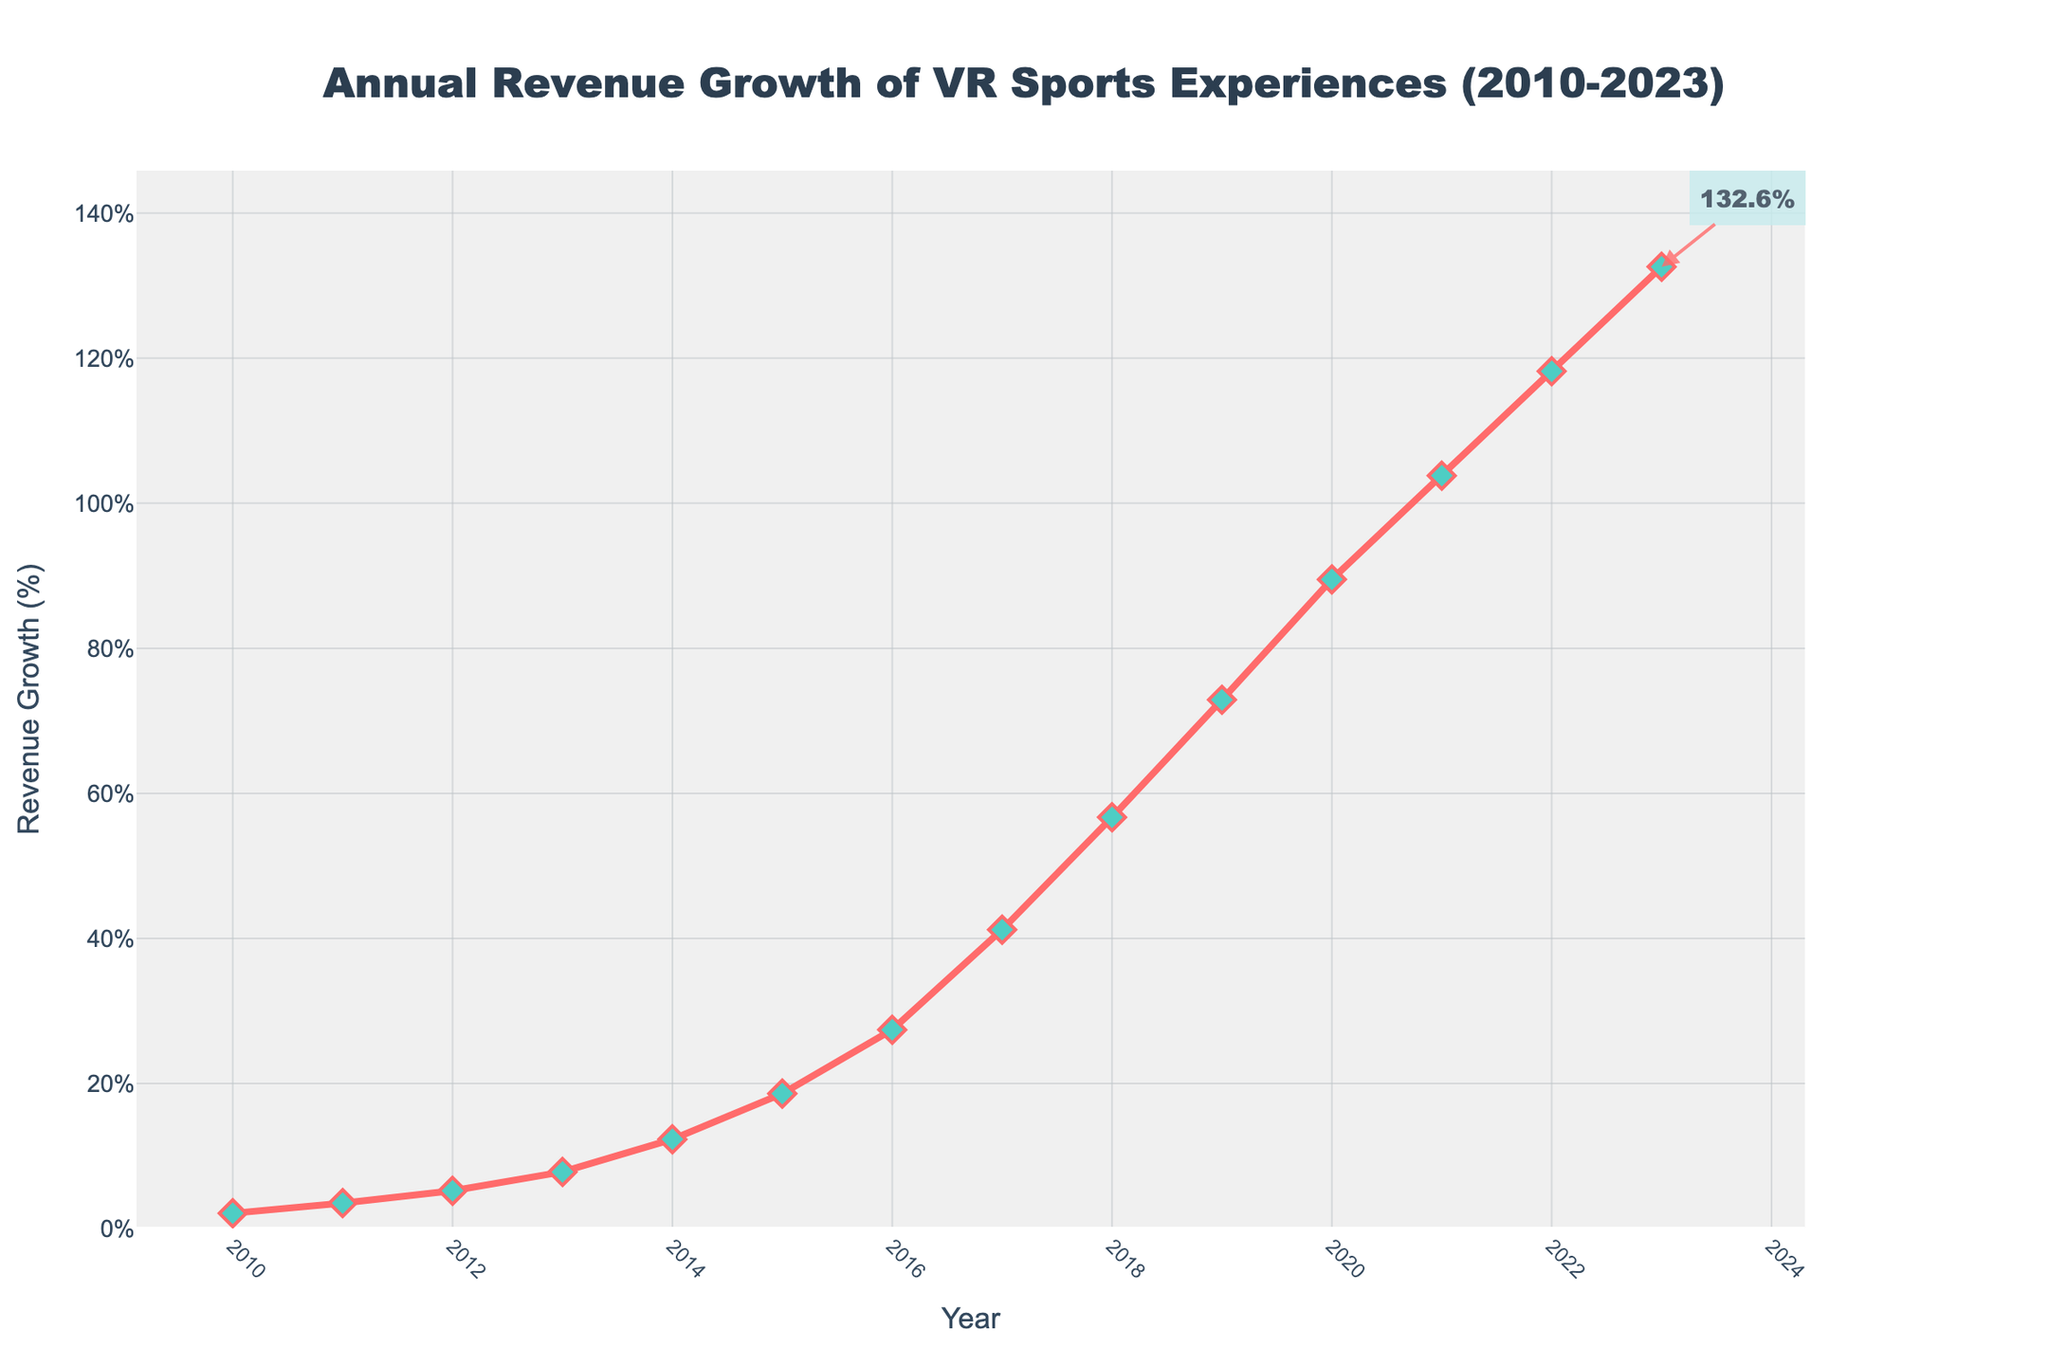What's the average annual revenue growth from 2010 to 2013? The revenue growth from 2010 to 2013 is 2.1%, 3.5%, 5.2%, and 7.8% respectively. Adding them: 2.1 + 3.5 + 5.2 + 7.8 = 18.6. Dividing by 4 gives the average: 18.6 / 4 = 4.65%
Answer: 4.65% Is the revenue growth in 2023 greater than in 2020? In 2023, the revenue growth is 132.6% and in 2020, it is 89.5%. Since 132.6 is greater than 89.5, the revenue growth in 2023 is greater than in 2020
Answer: Yes During which year did the revenue growth percentage surpass 50%? By looking at the data, we see that the revenue growth surpassed 50% in the year 2018 with a growth of 56.7%
Answer: 2018 How many times did the revenue growth increase by more than 15% from one year to the next? From 2010 to 2023: The increases above 15% are from 2016 to 2017 (27.4% to 41.2%, 13.8%), 2017 to 2018 (41.2% to 56.7%, 15.5%), 2018 to 2019 (56.7% to 72.9%, 16.2%), 2019 to 2020 (72.9% to 89.5%, 16.6%), 2020 to 2021 (89.5% to 103.8%, 14.3%), 2021 to 2022 (103.8% to 118.2%, 14.4%), and 2022 to 2023 (118.2% to 132.6%, 14.4%). Only the years 2017 to 2018, 2018 to 2019, and 2019 to 2020 show increases over 15%.
Answer: 3 What's the total revenue growth from 2010 to 2019? Adding the revenue growth percentages from 2010 to 2019: 2.1 + 3.5 + 5.2 + 7.8 + 12.3 + 18.6 + 27.4 + 41.2 + 56.7 + 72.9 = 247.7%
Answer: 247.7% Which year had the sharpest increase in revenue growth compared to the previous year? Calculating the differences year-by-year, the sharpest increase appears between 2019 (72.9%) and 2020 (89.5%), with an increase of 16.6%
Answer: 2020 How much revenue growth did VR sports experiences see from 2015 to 2023? To determine this, we find the difference between the values of revenue growth in 2023 (132.6%) and 2015 (18.6%): 132.6 - 18.6 = 114.0%
Answer: 114.0% What is the annual revenue growth trend from 2010 to 2015? Viewing the trend from 2010 to 2015: 2.1%, 3.5%, 5.2%, 7.8%, 12.3%, 18.6%; it shows a steadily increasing pattern each year
Answer: Increasing Is the increase in revenue growth from 2021 to 2022 similar to the increase from 2022 to 2023? The increase from 2021 to 2022 is 118.2% - 103.8% = 14.4%, and from 2022 to 2023 is 132.6% - 118.2% = 14.4%. They are the same.
Answer: Yes 